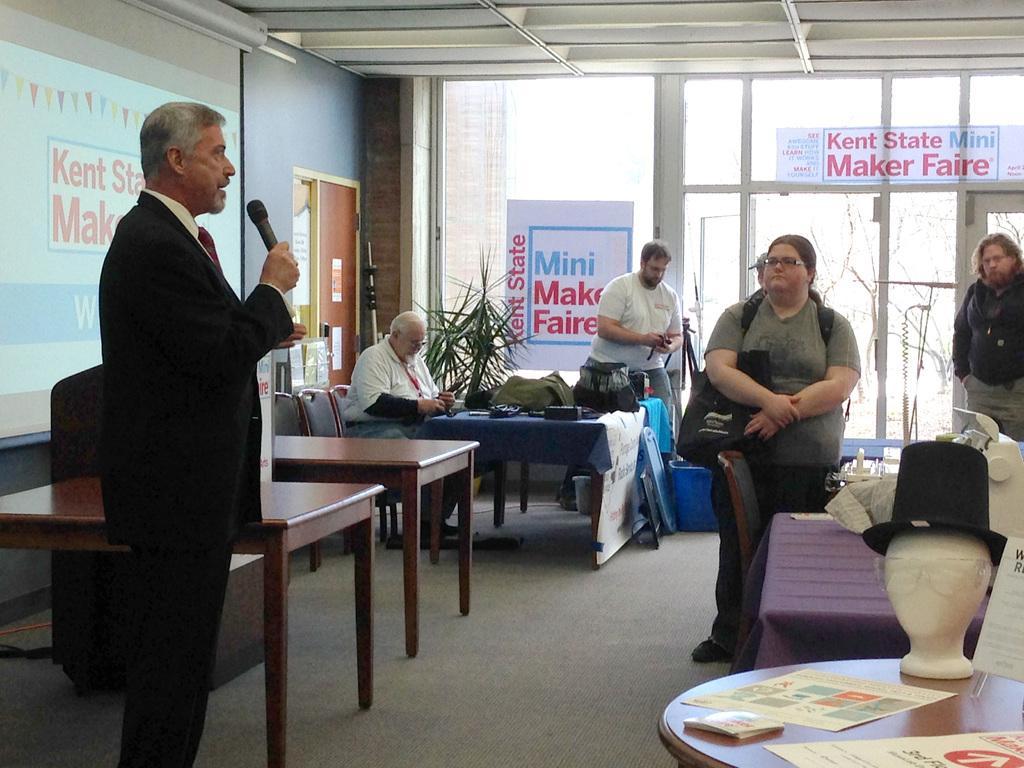Can you describe this image briefly? In this picture we can see some persons standing and listening to the person holding mic and talking and on right side we can see table, chair, person sitting and on table we have bags and in the background we can see window, banners, door, stuck here on table we can see some sculpture with goggles and cap on it , paper. 